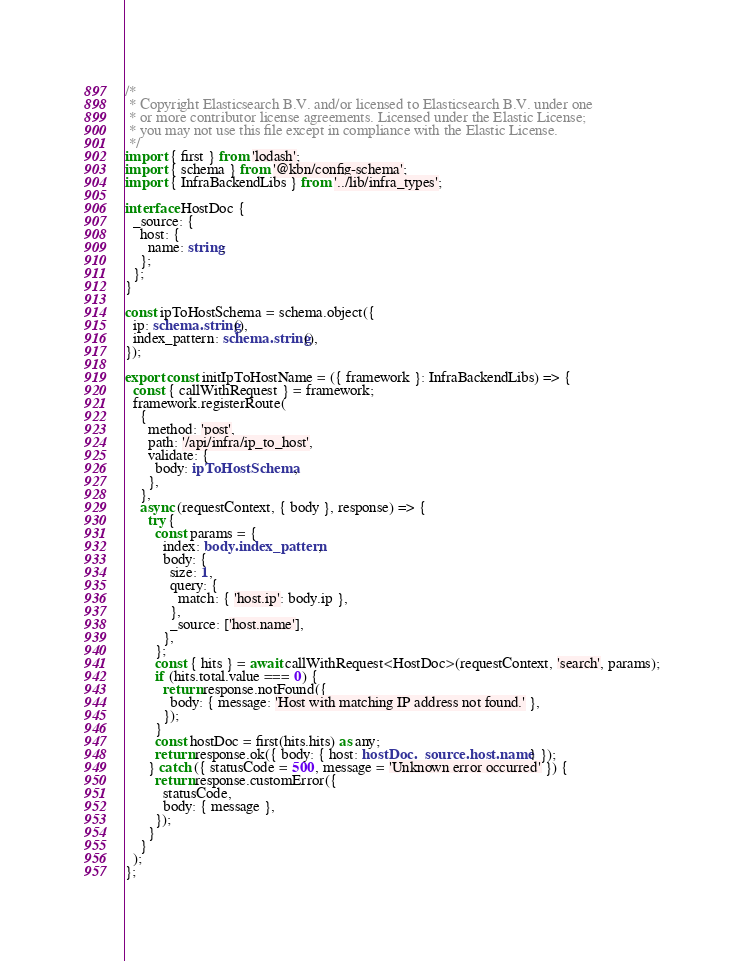<code> <loc_0><loc_0><loc_500><loc_500><_TypeScript_>/*
 * Copyright Elasticsearch B.V. and/or licensed to Elasticsearch B.V. under one
 * or more contributor license agreements. Licensed under the Elastic License;
 * you may not use this file except in compliance with the Elastic License.
 */
import { first } from 'lodash';
import { schema } from '@kbn/config-schema';
import { InfraBackendLibs } from '../lib/infra_types';

interface HostDoc {
  _source: {
    host: {
      name: string;
    };
  };
}

const ipToHostSchema = schema.object({
  ip: schema.string(),
  index_pattern: schema.string(),
});

export const initIpToHostName = ({ framework }: InfraBackendLibs) => {
  const { callWithRequest } = framework;
  framework.registerRoute(
    {
      method: 'post',
      path: '/api/infra/ip_to_host',
      validate: {
        body: ipToHostSchema,
      },
    },
    async (requestContext, { body }, response) => {
      try {
        const params = {
          index: body.index_pattern,
          body: {
            size: 1,
            query: {
              match: { 'host.ip': body.ip },
            },
            _source: ['host.name'],
          },
        };
        const { hits } = await callWithRequest<HostDoc>(requestContext, 'search', params);
        if (hits.total.value === 0) {
          return response.notFound({
            body: { message: 'Host with matching IP address not found.' },
          });
        }
        const hostDoc = first(hits.hits) as any;
        return response.ok({ body: { host: hostDoc._source.host.name } });
      } catch ({ statusCode = 500, message = 'Unknown error occurred' }) {
        return response.customError({
          statusCode,
          body: { message },
        });
      }
    }
  );
};
</code> 